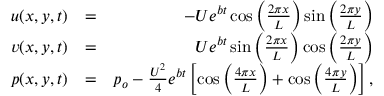Convert formula to latex. <formula><loc_0><loc_0><loc_500><loc_500>\begin{array} { r l r } { u ( x , y , t ) } & { = } & { - U e ^ { b t } \cos { \left ( \frac { 2 \pi x } { L } \right ) } \sin { \left ( \frac { 2 \pi y } { L } \right ) } } \\ { v ( x , y , t ) } & { = } & { U e ^ { b t } \sin { \left ( \frac { 2 \pi x } { L } \right ) } \cos { \left ( \frac { 2 \pi y } { L } \right ) } } \\ { p ( x , y , t ) } & { = } & { p _ { o } - \frac { U ^ { 2 } } { 4 } e ^ { b t } \left [ \cos { \left ( \frac { 4 \pi x } { L } \right ) } + \cos { \left ( \frac { 4 \pi y } { L } \right ) } \right ] , } \end{array}</formula> 